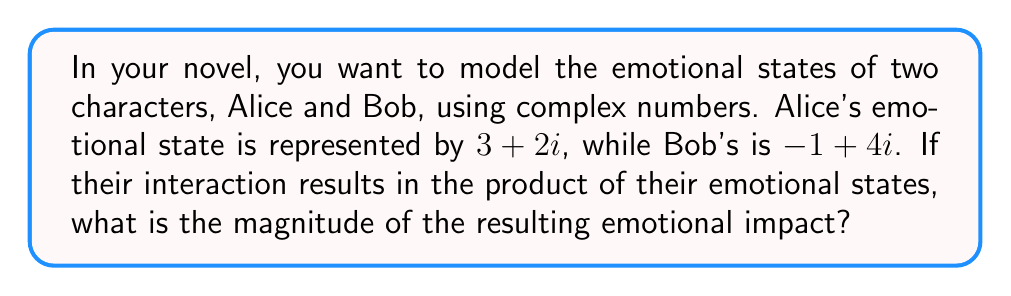Can you answer this question? To solve this problem, we'll follow these steps:

1) First, let's recall that the product of two complex numbers $(a+bi)(c+di)$ is given by:
   $$(a+bi)(c+di) = (ac-bd) + (ad+bc)i$$

2) In this case, Alice's state is $3+2i$ and Bob's is $-1+4i$. Let's multiply them:
   $$(3+2i)(-1+4i) = (-3-12) + (12-2)i = -15 + 10i$$

3) The magnitude of a complex number $a+bi$ is given by $\sqrt{a^2 + b^2}$. 

4) For our result $-15 + 10i$, we need to calculate:
   $$\sqrt{(-15)^2 + (10)^2}$$

5) Simplify:
   $$\sqrt{225 + 100} = \sqrt{325}$$

6) The square root of 325 can be simplified to $5\sqrt{13}$.

Therefore, the magnitude of the emotional impact is $5\sqrt{13}$.
Answer: $5\sqrt{13}$ 